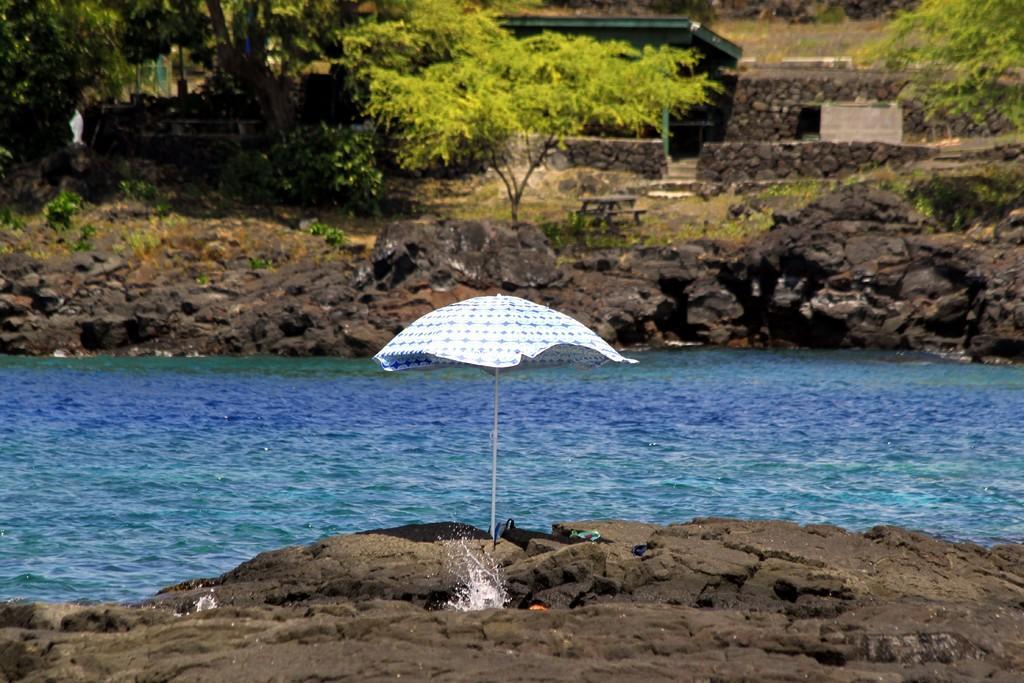In one or two sentences, can you explain what this image depicts? In the image there is a river and on the either side of the river there is a rock surface, there is an umbrella in between the rocks, in the background there are few trees. 